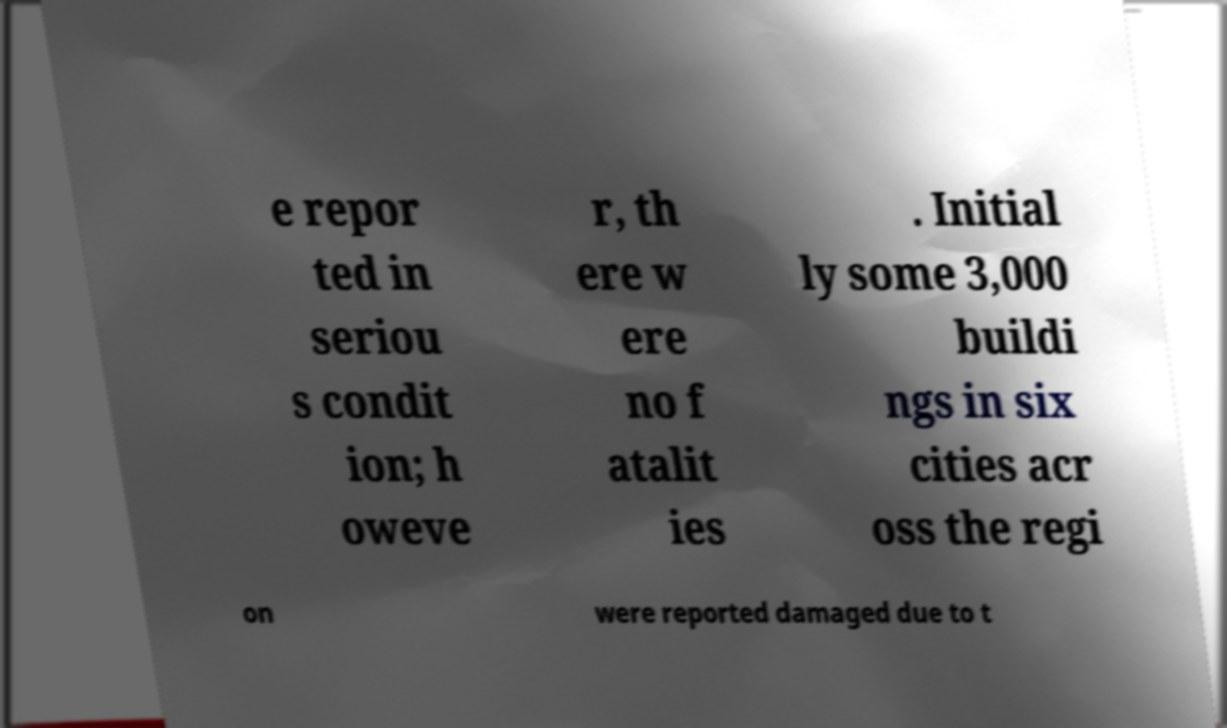Could you extract and type out the text from this image? e repor ted in seriou s condit ion; h oweve r, th ere w ere no f atalit ies . Initial ly some 3,000 buildi ngs in six cities acr oss the regi on were reported damaged due to t 